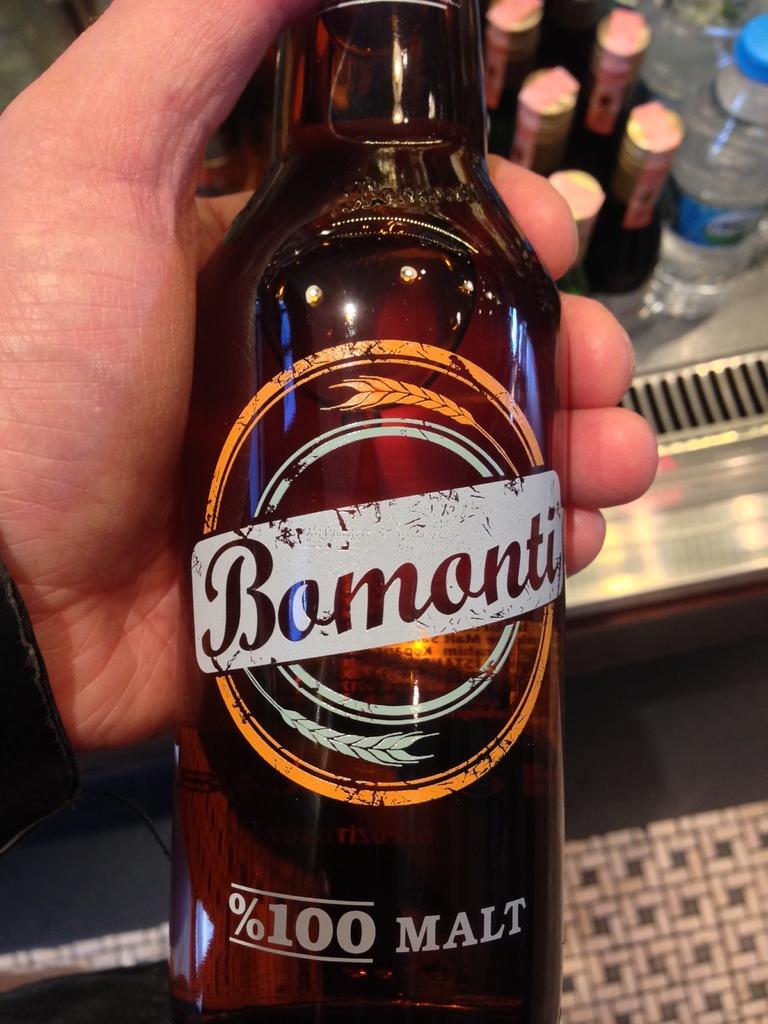Could you give a brief overview of what you see in this image? Here we can see a bottle in a person's hand and behind that we can see a number of bottles 